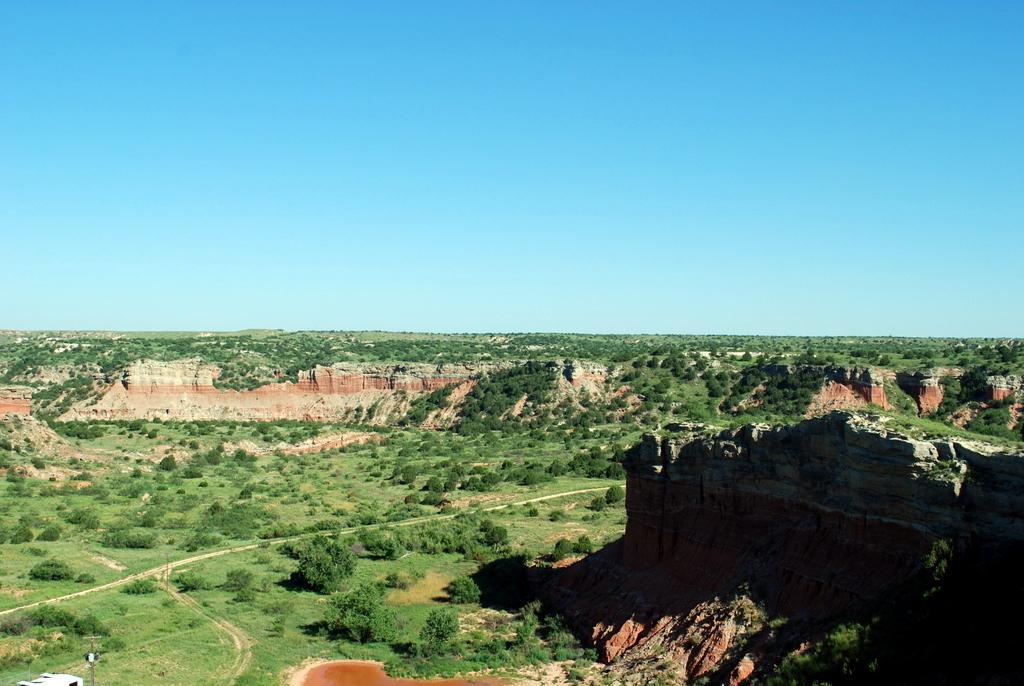Could you give a brief overview of what you see in this image? In this image we can see vast plateau land where we can see plants and grass. At the top of the image, sky is there which is in blue color. 